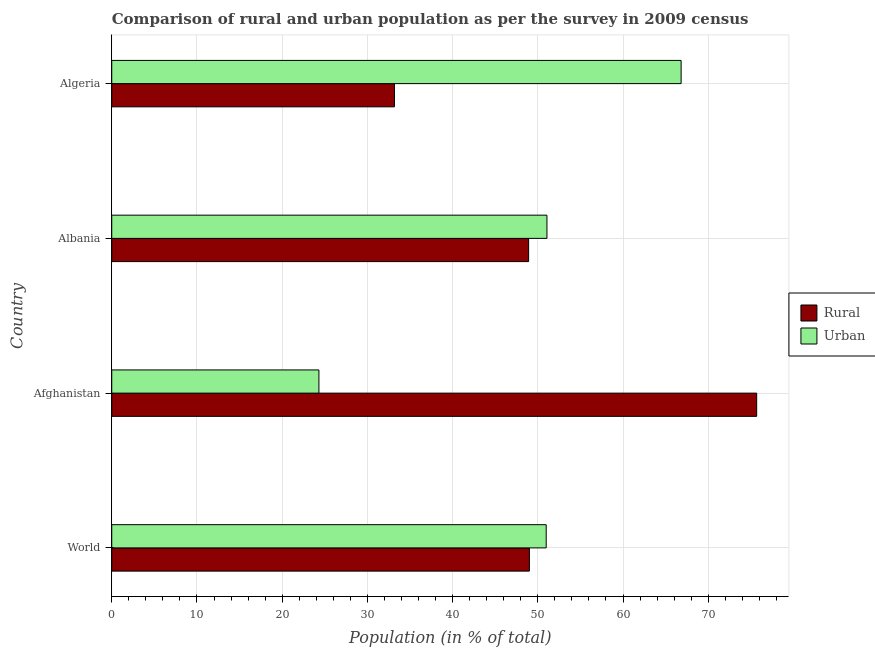How many different coloured bars are there?
Provide a succinct answer. 2. How many groups of bars are there?
Your answer should be very brief. 4. Are the number of bars on each tick of the Y-axis equal?
Your response must be concise. Yes. How many bars are there on the 4th tick from the bottom?
Give a very brief answer. 2. What is the label of the 2nd group of bars from the top?
Give a very brief answer. Albania. In how many cases, is the number of bars for a given country not equal to the number of legend labels?
Give a very brief answer. 0. What is the rural population in Afghanistan?
Make the answer very short. 75.69. Across all countries, what is the maximum urban population?
Offer a terse response. 66.82. Across all countries, what is the minimum urban population?
Keep it short and to the point. 24.31. In which country was the urban population maximum?
Make the answer very short. Algeria. In which country was the urban population minimum?
Your response must be concise. Afghanistan. What is the total urban population in the graph?
Provide a short and direct response. 193.2. What is the difference between the urban population in Algeria and that in World?
Provide a succinct answer. 15.84. What is the difference between the rural population in Albania and the urban population in Algeria?
Your answer should be very brief. -17.9. What is the average urban population per country?
Offer a very short reply. 48.3. What is the difference between the urban population and rural population in World?
Make the answer very short. 1.97. What is the ratio of the rural population in Algeria to that in World?
Your response must be concise. 0.68. Is the rural population in Albania less than that in World?
Offer a terse response. Yes. Is the difference between the rural population in Afghanistan and World greater than the difference between the urban population in Afghanistan and World?
Your answer should be compact. Yes. What is the difference between the highest and the second highest rural population?
Your answer should be very brief. 26.67. What is the difference between the highest and the lowest urban population?
Offer a terse response. 42.51. What does the 2nd bar from the top in Afghanistan represents?
Your response must be concise. Rural. What does the 1st bar from the bottom in Albania represents?
Keep it short and to the point. Rural. How many bars are there?
Your answer should be compact. 8. Are all the bars in the graph horizontal?
Your answer should be very brief. Yes. How many countries are there in the graph?
Give a very brief answer. 4. What is the difference between two consecutive major ticks on the X-axis?
Ensure brevity in your answer.  10. Are the values on the major ticks of X-axis written in scientific E-notation?
Your response must be concise. No. Does the graph contain grids?
Keep it short and to the point. Yes. How are the legend labels stacked?
Provide a short and direct response. Vertical. What is the title of the graph?
Your answer should be compact. Comparison of rural and urban population as per the survey in 2009 census. What is the label or title of the X-axis?
Keep it short and to the point. Population (in % of total). What is the label or title of the Y-axis?
Offer a terse response. Country. What is the Population (in % of total) in Rural in World?
Provide a short and direct response. 49.01. What is the Population (in % of total) of Urban in World?
Offer a very short reply. 50.99. What is the Population (in % of total) in Rural in Afghanistan?
Provide a short and direct response. 75.69. What is the Population (in % of total) of Urban in Afghanistan?
Your response must be concise. 24.31. What is the Population (in % of total) of Rural in Albania?
Your answer should be compact. 48.92. What is the Population (in % of total) in Urban in Albania?
Provide a short and direct response. 51.08. What is the Population (in % of total) in Rural in Algeria?
Give a very brief answer. 33.18. What is the Population (in % of total) in Urban in Algeria?
Give a very brief answer. 66.82. Across all countries, what is the maximum Population (in % of total) of Rural?
Provide a succinct answer. 75.69. Across all countries, what is the maximum Population (in % of total) in Urban?
Your answer should be compact. 66.82. Across all countries, what is the minimum Population (in % of total) of Rural?
Give a very brief answer. 33.18. Across all countries, what is the minimum Population (in % of total) in Urban?
Provide a succinct answer. 24.31. What is the total Population (in % of total) of Rural in the graph?
Give a very brief answer. 206.8. What is the total Population (in % of total) in Urban in the graph?
Your response must be concise. 193.2. What is the difference between the Population (in % of total) in Rural in World and that in Afghanistan?
Your answer should be compact. -26.67. What is the difference between the Population (in % of total) in Urban in World and that in Afghanistan?
Provide a short and direct response. 26.67. What is the difference between the Population (in % of total) in Rural in World and that in Albania?
Offer a terse response. 0.09. What is the difference between the Population (in % of total) in Urban in World and that in Albania?
Offer a terse response. -0.09. What is the difference between the Population (in % of total) of Rural in World and that in Algeria?
Offer a terse response. 15.84. What is the difference between the Population (in % of total) of Urban in World and that in Algeria?
Your answer should be compact. -15.84. What is the difference between the Population (in % of total) of Rural in Afghanistan and that in Albania?
Your answer should be very brief. 26.76. What is the difference between the Population (in % of total) in Urban in Afghanistan and that in Albania?
Ensure brevity in your answer.  -26.76. What is the difference between the Population (in % of total) in Rural in Afghanistan and that in Algeria?
Your response must be concise. 42.51. What is the difference between the Population (in % of total) of Urban in Afghanistan and that in Algeria?
Ensure brevity in your answer.  -42.51. What is the difference between the Population (in % of total) in Rural in Albania and that in Algeria?
Your response must be concise. 15.75. What is the difference between the Population (in % of total) of Urban in Albania and that in Algeria?
Give a very brief answer. -15.75. What is the difference between the Population (in % of total) in Rural in World and the Population (in % of total) in Urban in Afghanistan?
Provide a succinct answer. 24.7. What is the difference between the Population (in % of total) of Rural in World and the Population (in % of total) of Urban in Albania?
Make the answer very short. -2.06. What is the difference between the Population (in % of total) in Rural in World and the Population (in % of total) in Urban in Algeria?
Your response must be concise. -17.81. What is the difference between the Population (in % of total) in Rural in Afghanistan and the Population (in % of total) in Urban in Albania?
Ensure brevity in your answer.  24.61. What is the difference between the Population (in % of total) in Rural in Afghanistan and the Population (in % of total) in Urban in Algeria?
Provide a short and direct response. 8.87. What is the difference between the Population (in % of total) in Rural in Albania and the Population (in % of total) in Urban in Algeria?
Offer a terse response. -17.9. What is the average Population (in % of total) in Rural per country?
Your response must be concise. 51.7. What is the average Population (in % of total) of Urban per country?
Give a very brief answer. 48.3. What is the difference between the Population (in % of total) of Rural and Population (in % of total) of Urban in World?
Ensure brevity in your answer.  -1.97. What is the difference between the Population (in % of total) of Rural and Population (in % of total) of Urban in Afghanistan?
Make the answer very short. 51.37. What is the difference between the Population (in % of total) in Rural and Population (in % of total) in Urban in Albania?
Offer a very short reply. -2.15. What is the difference between the Population (in % of total) in Rural and Population (in % of total) in Urban in Algeria?
Ensure brevity in your answer.  -33.64. What is the ratio of the Population (in % of total) in Rural in World to that in Afghanistan?
Your answer should be very brief. 0.65. What is the ratio of the Population (in % of total) in Urban in World to that in Afghanistan?
Make the answer very short. 2.1. What is the ratio of the Population (in % of total) of Rural in World to that in Algeria?
Offer a very short reply. 1.48. What is the ratio of the Population (in % of total) of Urban in World to that in Algeria?
Your response must be concise. 0.76. What is the ratio of the Population (in % of total) in Rural in Afghanistan to that in Albania?
Your answer should be compact. 1.55. What is the ratio of the Population (in % of total) in Urban in Afghanistan to that in Albania?
Give a very brief answer. 0.48. What is the ratio of the Population (in % of total) of Rural in Afghanistan to that in Algeria?
Your answer should be compact. 2.28. What is the ratio of the Population (in % of total) in Urban in Afghanistan to that in Algeria?
Provide a short and direct response. 0.36. What is the ratio of the Population (in % of total) in Rural in Albania to that in Algeria?
Keep it short and to the point. 1.47. What is the ratio of the Population (in % of total) of Urban in Albania to that in Algeria?
Make the answer very short. 0.76. What is the difference between the highest and the second highest Population (in % of total) of Rural?
Ensure brevity in your answer.  26.67. What is the difference between the highest and the second highest Population (in % of total) of Urban?
Offer a very short reply. 15.75. What is the difference between the highest and the lowest Population (in % of total) in Rural?
Your answer should be very brief. 42.51. What is the difference between the highest and the lowest Population (in % of total) in Urban?
Make the answer very short. 42.51. 